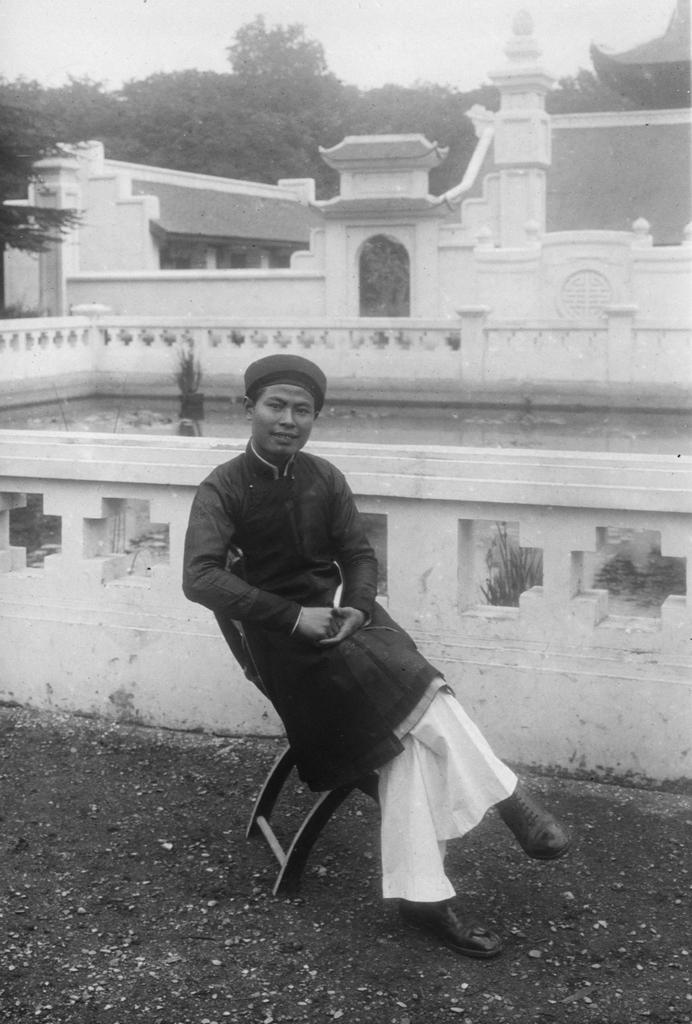What is the man in the image doing? The man is sitting in a chair in the image. What color are the walls in the image? The walls in the image are white. What can be seen in the background of the image? There are trees and the sky visible in the background of the image. How is the image presented? The image is black and white. How does the lamp in the image affect the man's wish? There is no lamp present in the image, so it cannot affect the man's wish. 